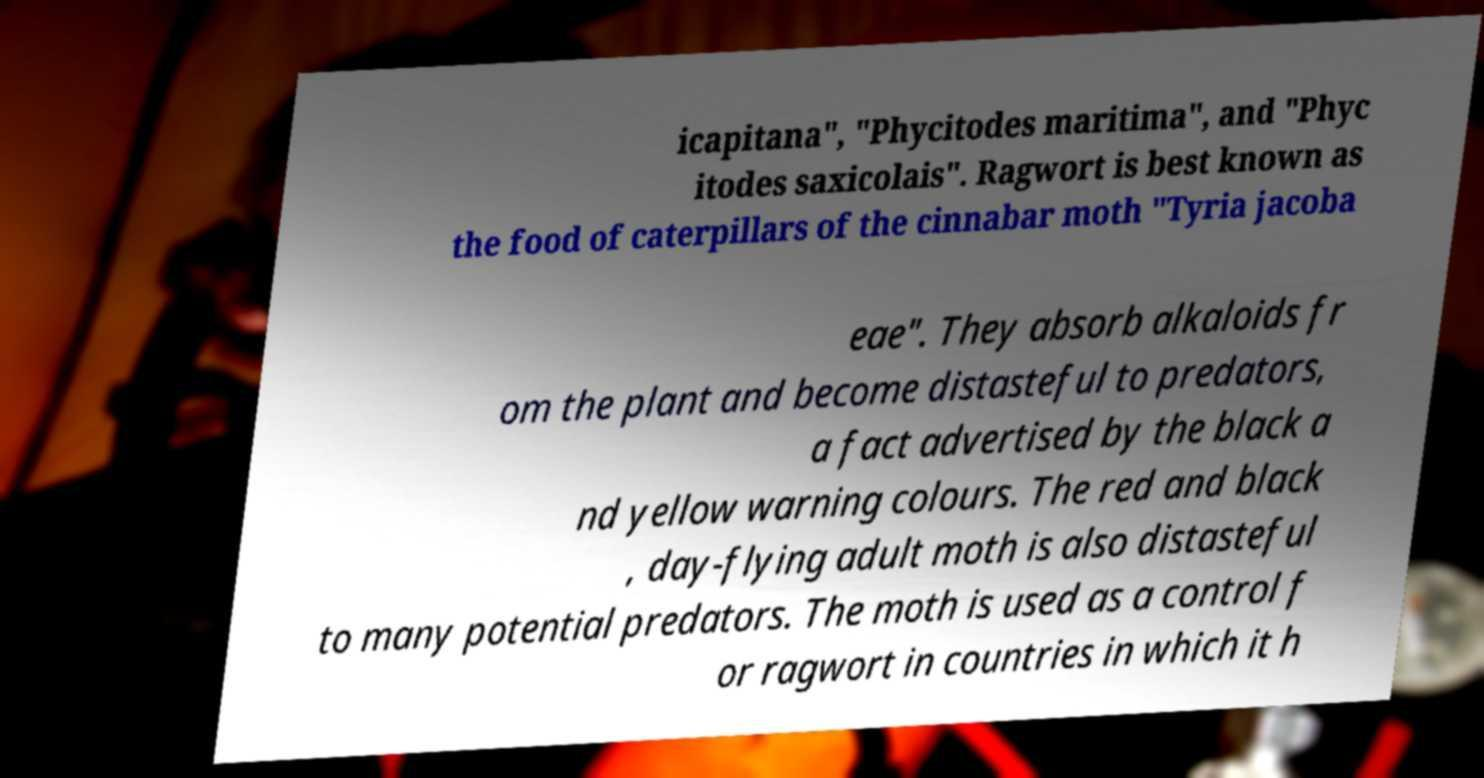Could you extract and type out the text from this image? icapitana", "Phycitodes maritima", and "Phyc itodes saxicolais". Ragwort is best known as the food of caterpillars of the cinnabar moth "Tyria jacoba eae". They absorb alkaloids fr om the plant and become distasteful to predators, a fact advertised by the black a nd yellow warning colours. The red and black , day-flying adult moth is also distasteful to many potential predators. The moth is used as a control f or ragwort in countries in which it h 